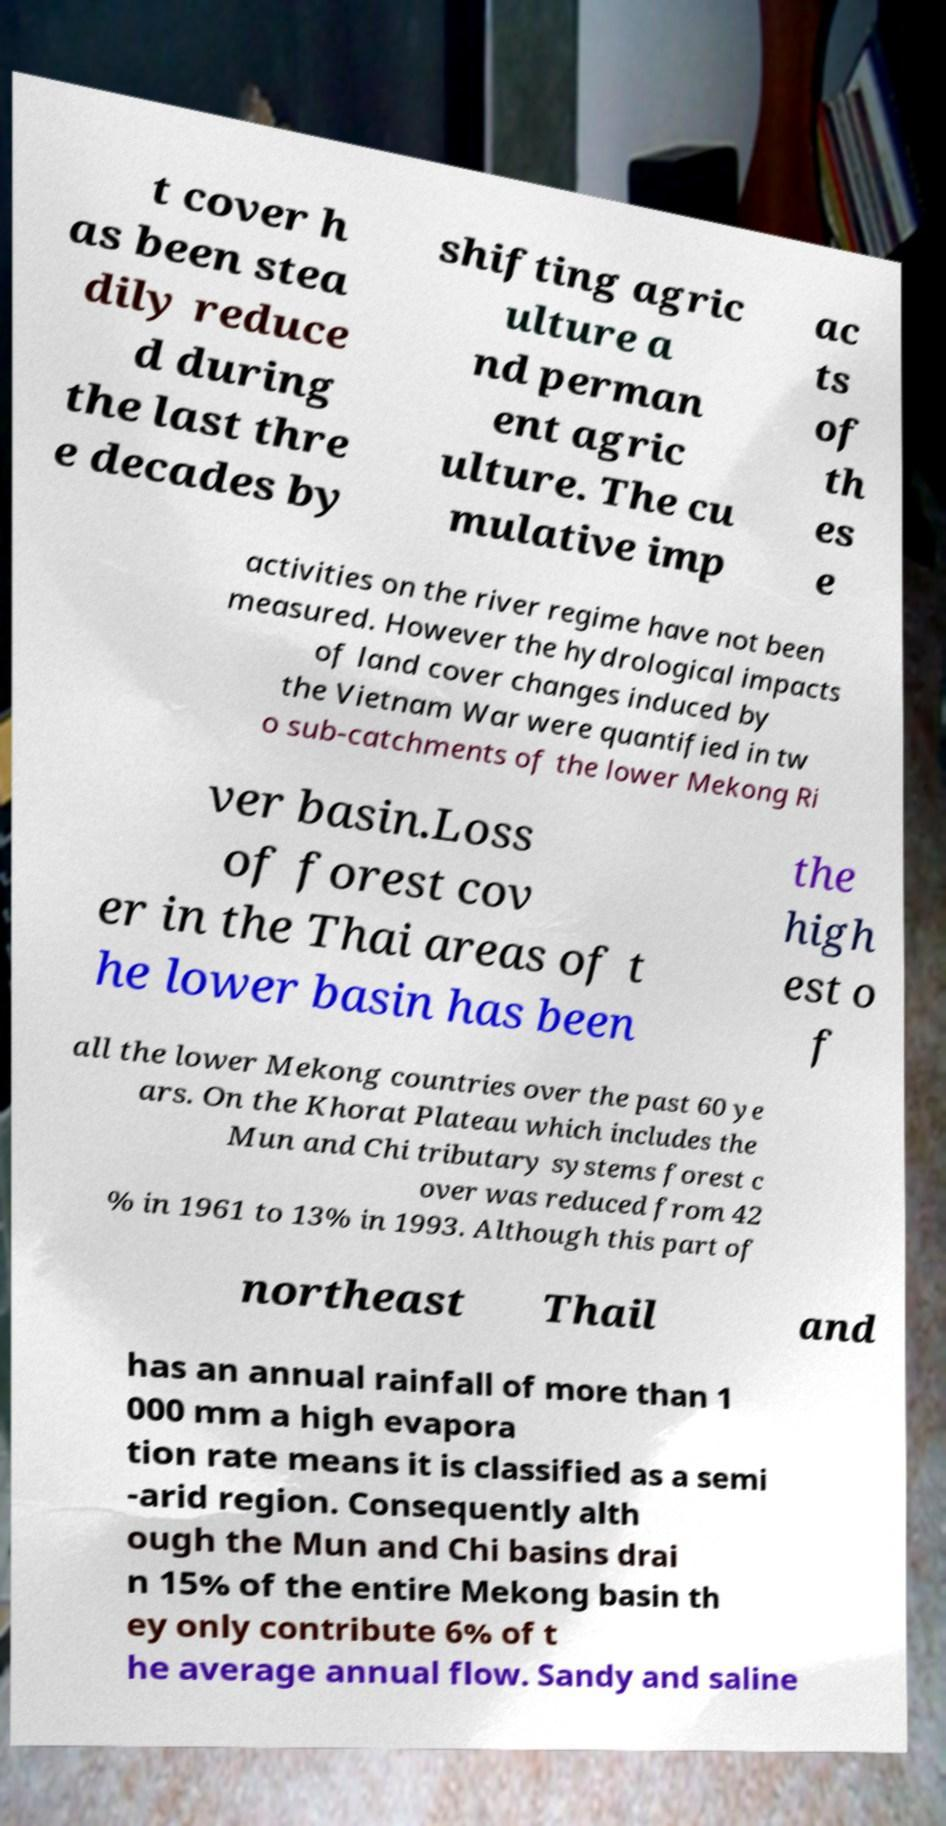Can you accurately transcribe the text from the provided image for me? t cover h as been stea dily reduce d during the last thre e decades by shifting agric ulture a nd perman ent agric ulture. The cu mulative imp ac ts of th es e activities on the river regime have not been measured. However the hydrological impacts of land cover changes induced by the Vietnam War were quantified in tw o sub-catchments of the lower Mekong Ri ver basin.Loss of forest cov er in the Thai areas of t he lower basin has been the high est o f all the lower Mekong countries over the past 60 ye ars. On the Khorat Plateau which includes the Mun and Chi tributary systems forest c over was reduced from 42 % in 1961 to 13% in 1993. Although this part of northeast Thail and has an annual rainfall of more than 1 000 mm a high evapora tion rate means it is classified as a semi -arid region. Consequently alth ough the Mun and Chi basins drai n 15% of the entire Mekong basin th ey only contribute 6% of t he average annual flow. Sandy and saline 